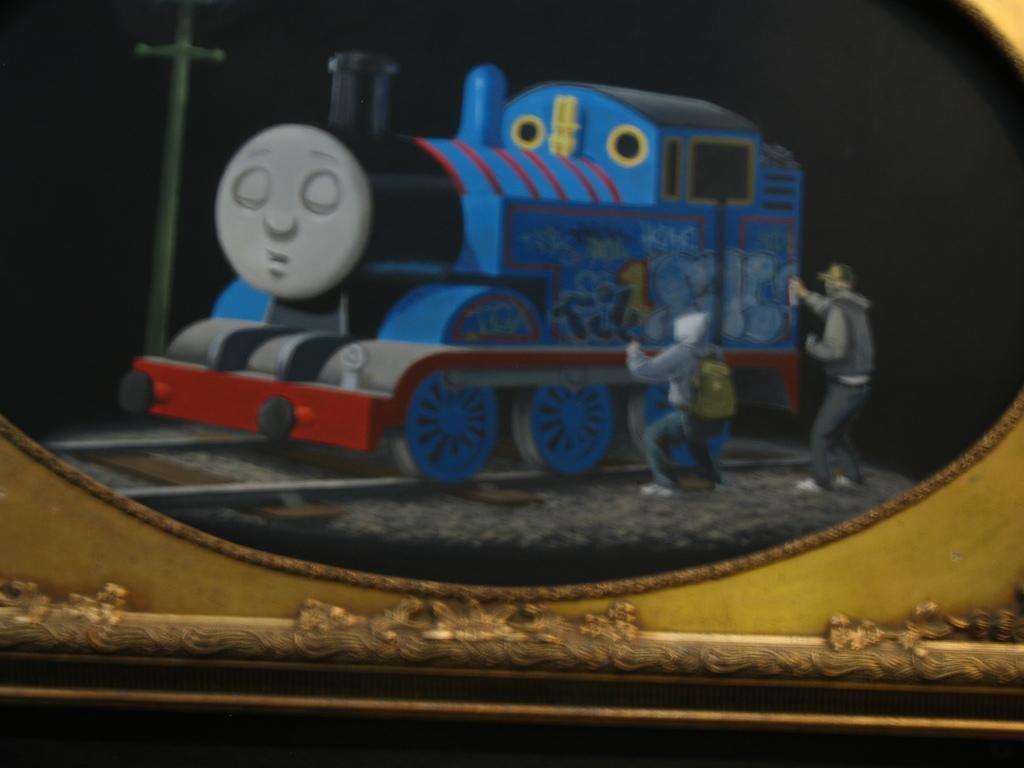How would you summarize this image in a sentence or two? In the image we can see the train toy and we can see there are people wearing clothes, shoes and caps. Here we can see the pole and the background is dark. 